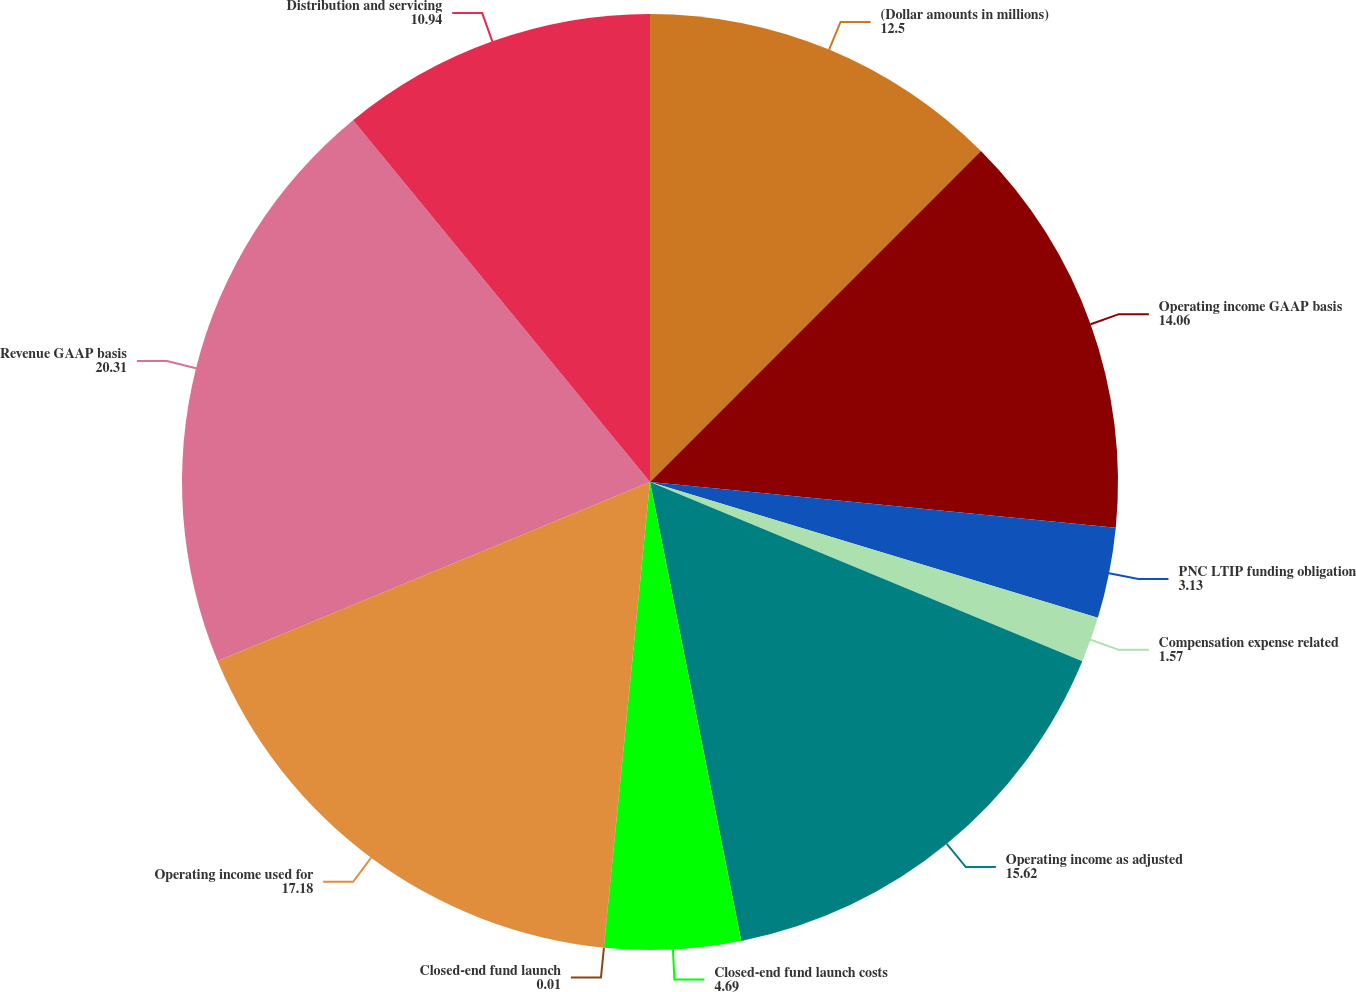Convert chart. <chart><loc_0><loc_0><loc_500><loc_500><pie_chart><fcel>(Dollar amounts in millions)<fcel>Operating income GAAP basis<fcel>PNC LTIP funding obligation<fcel>Compensation expense related<fcel>Operating income as adjusted<fcel>Closed-end fund launch costs<fcel>Closed-end fund launch<fcel>Operating income used for<fcel>Revenue GAAP basis<fcel>Distribution and servicing<nl><fcel>12.5%<fcel>14.06%<fcel>3.13%<fcel>1.57%<fcel>15.62%<fcel>4.69%<fcel>0.01%<fcel>17.18%<fcel>20.31%<fcel>10.94%<nl></chart> 